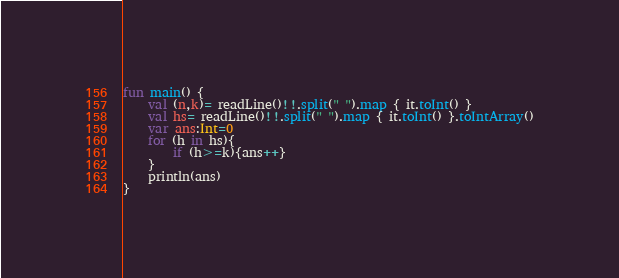Convert code to text. <code><loc_0><loc_0><loc_500><loc_500><_Kotlin_>fun main() {
    val (n,k)= readLine()!!.split(" ").map { it.toInt() }
    val hs= readLine()!!.split(" ").map { it.toInt() }.toIntArray()
    var ans:Int=0
    for (h in hs){
        if (h>=k){ans++}
    }
    println(ans)
}</code> 